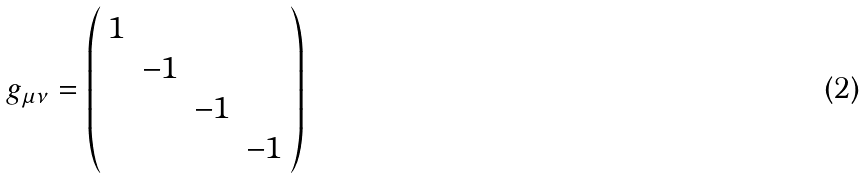Convert formula to latex. <formula><loc_0><loc_0><loc_500><loc_500>g _ { \mu \nu } = \left ( \begin{array} { c c c c } 1 & & & \\ & - 1 & & \\ & & - 1 & \\ & & & - 1 \\ \end{array} \right )</formula> 